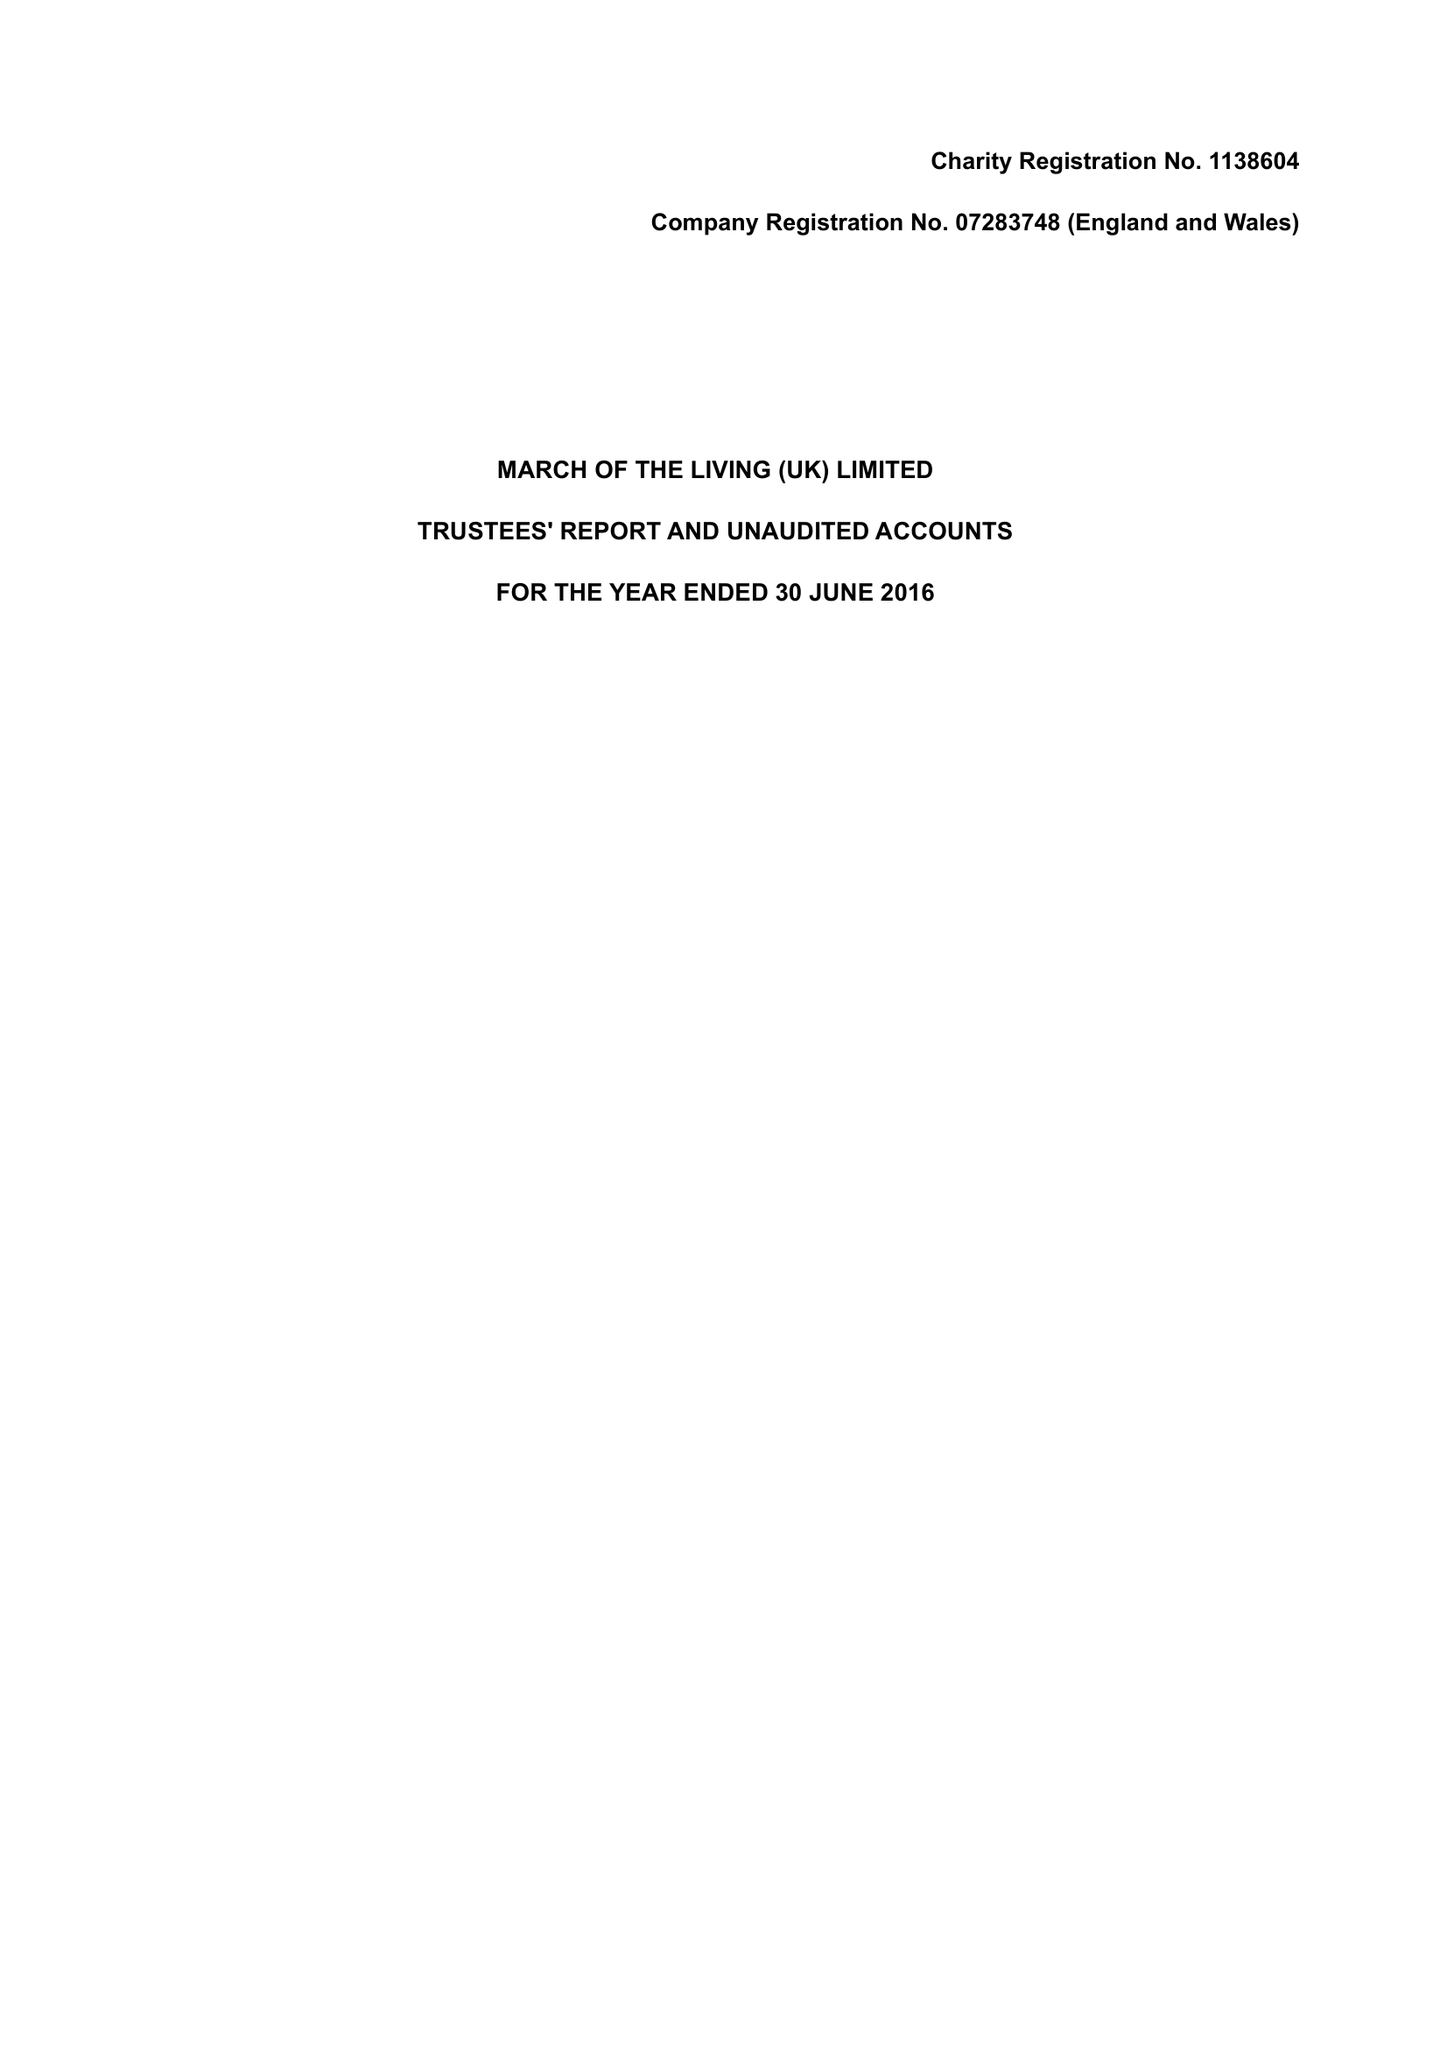What is the value for the address__post_town?
Answer the question using a single word or phrase. LONDON 